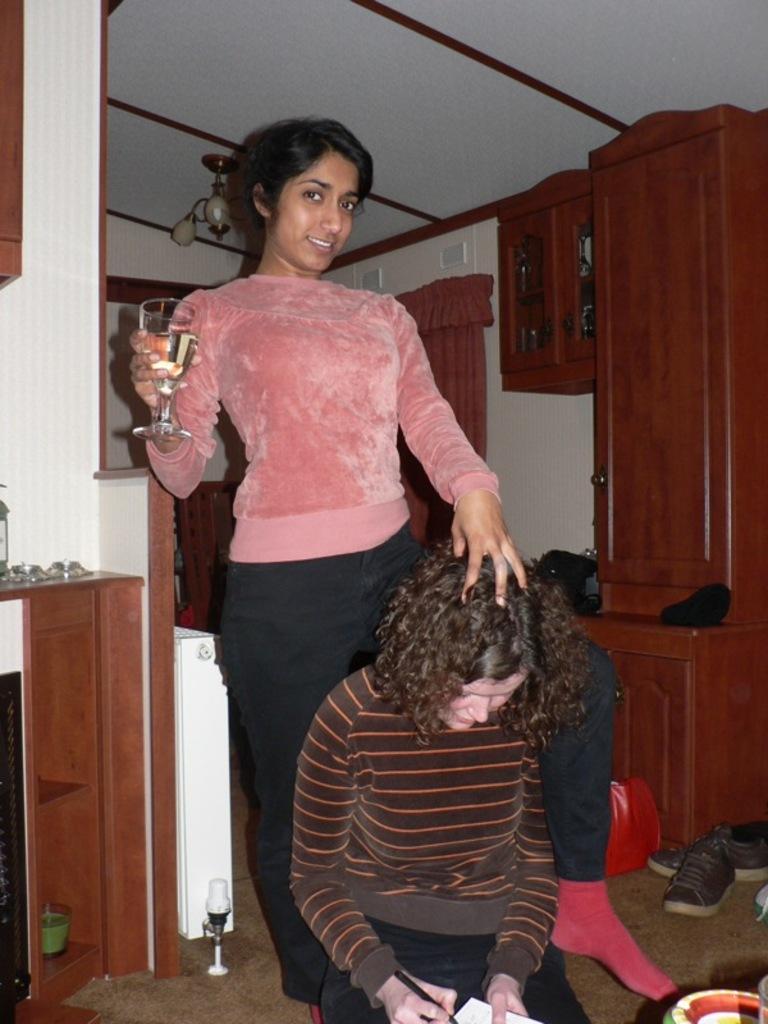Can you describe this image briefly? Here we can see a woman writing with a pen on a book by holding in her hands and there is another woman standing by holding a wine glass in her hand. In the background there is a light on the roof top,wall,curtain,cupboards,shoes,candle with stand and some other objects on the floor. We can also see some other objects on the table on the left side. 